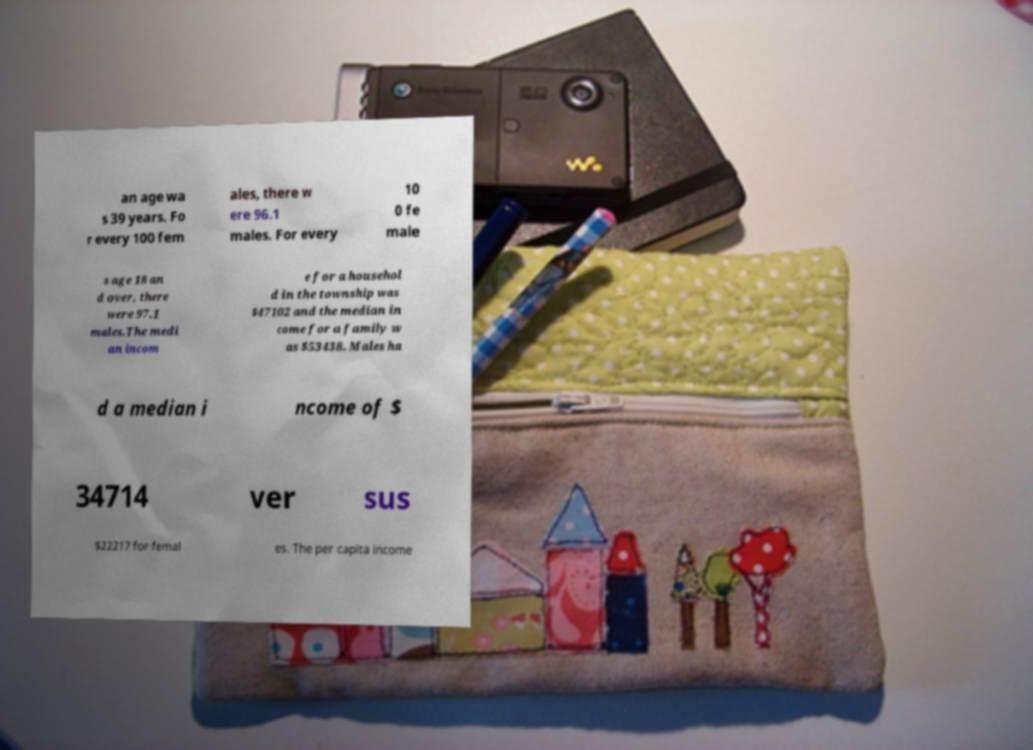Can you accurately transcribe the text from the provided image for me? an age wa s 39 years. Fo r every 100 fem ales, there w ere 96.1 males. For every 10 0 fe male s age 18 an d over, there were 97.1 males.The medi an incom e for a househol d in the township was $47102 and the median in come for a family w as $53438. Males ha d a median i ncome of $ 34714 ver sus $22217 for femal es. The per capita income 